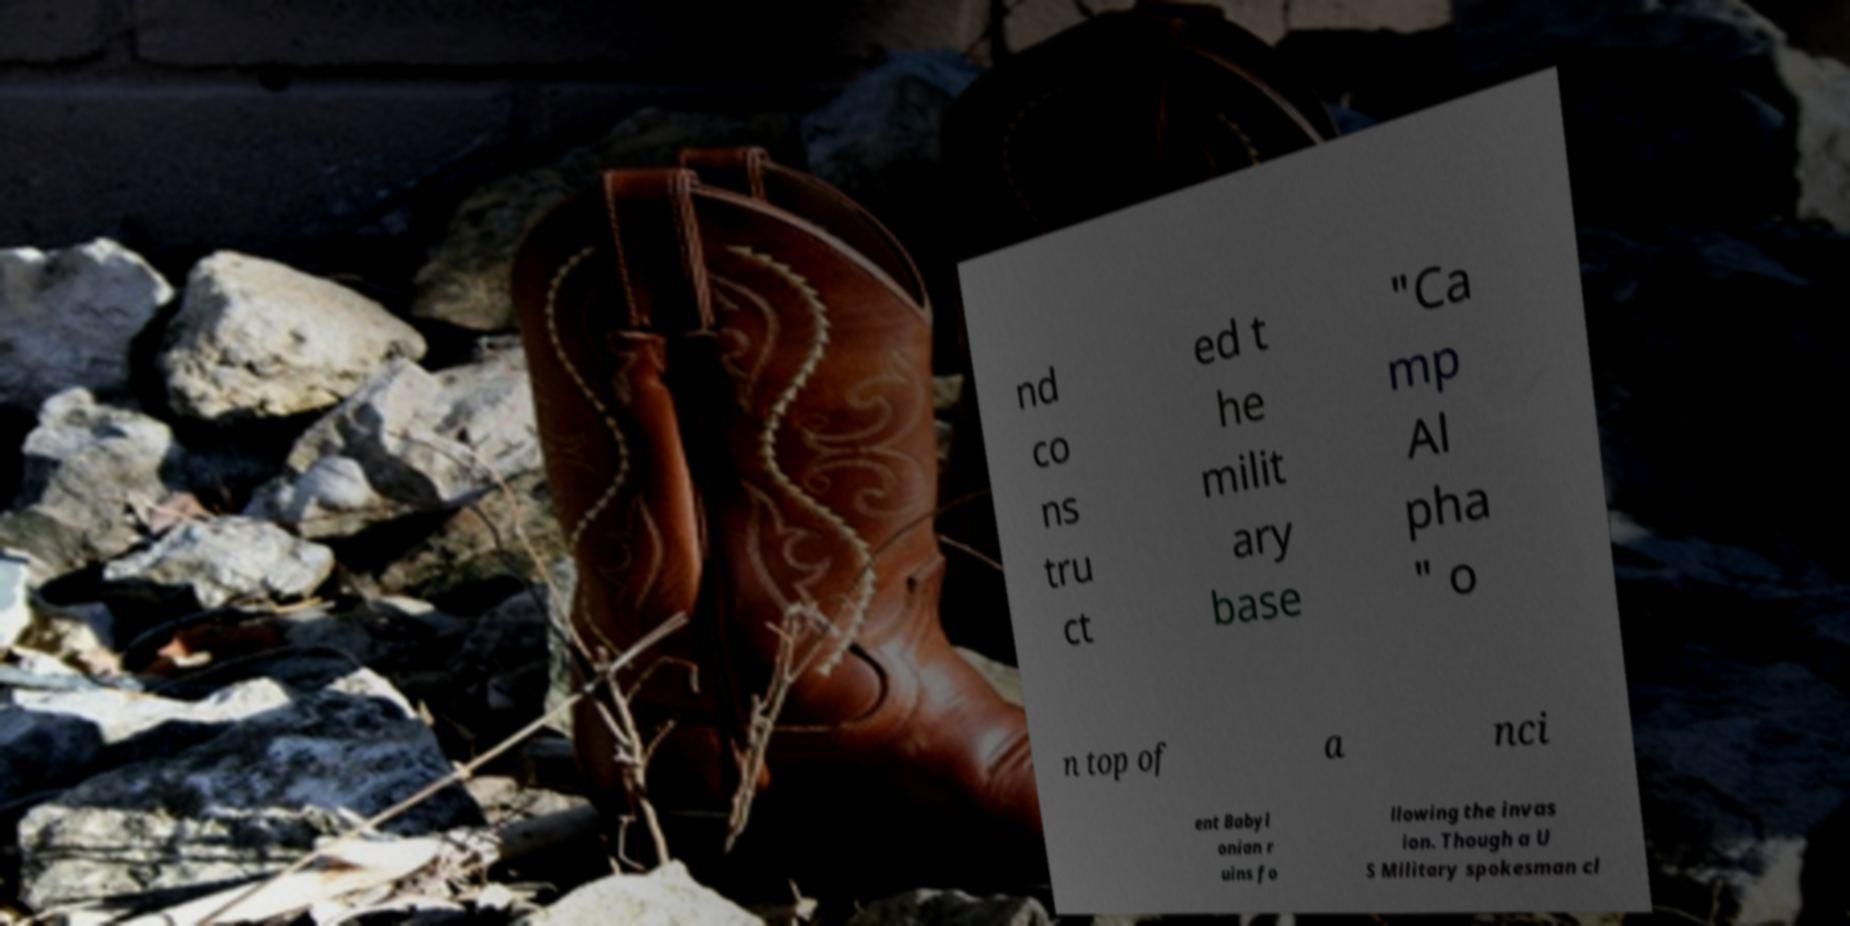There's text embedded in this image that I need extracted. Can you transcribe it verbatim? nd co ns tru ct ed t he milit ary base "Ca mp Al pha " o n top of a nci ent Babyl onian r uins fo llowing the invas ion. Though a U S Military spokesman cl 